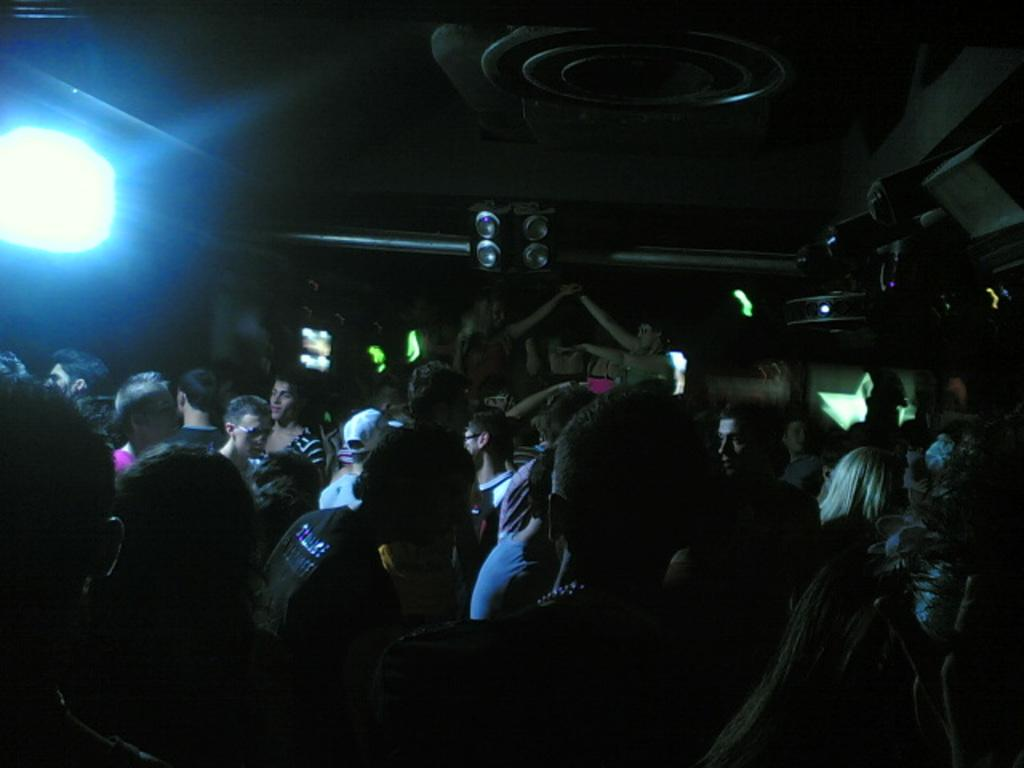What is the main subject of the image? The main subject of the image is a crowd. What can be seen at the top of the image? There are speakers and a focusing light at the top of the image. What type of ring can be seen on the finger of the person in the crowd? There is no person in the crowd with a ring visible in the image. What ornament is hanging from the focusing light in the image? There is no ornament hanging from the focusing light in the image; only the light is visible. 